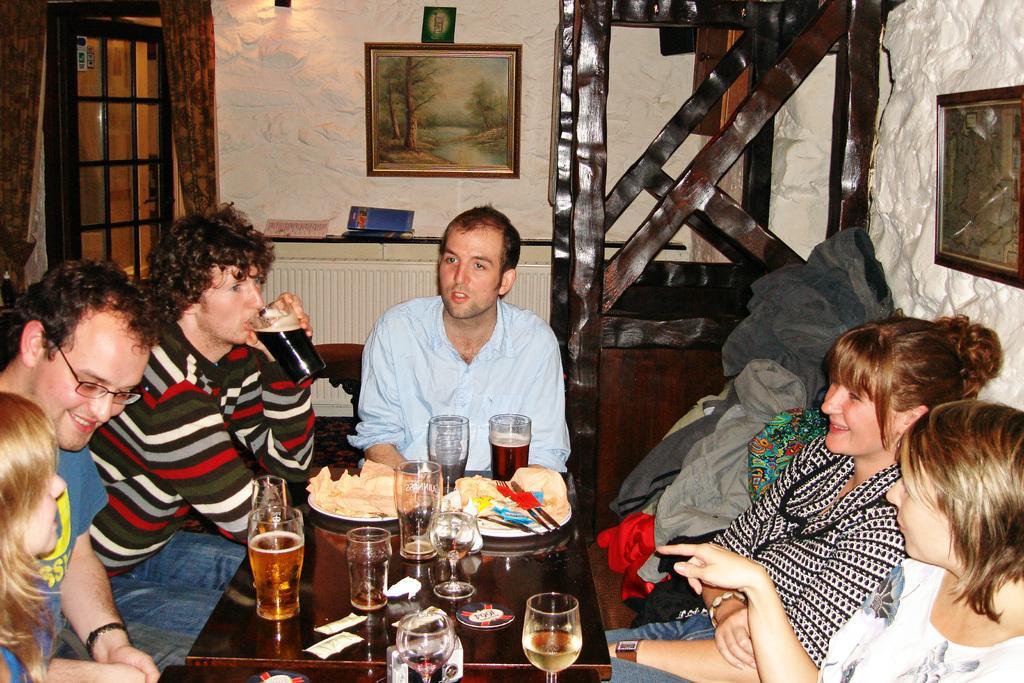Can you describe this image briefly? It's a closed room. Three men and three women are there in front of them, there is a table and some glasses are on the table. one person is drinking, behind them their is a wall and a painting on it and a door behind them, the curtains. The girl is smiling, behind them their is a another painting on the wall and one person is wearing glasses. 